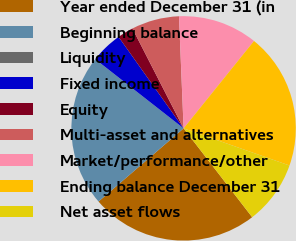<chart> <loc_0><loc_0><loc_500><loc_500><pie_chart><fcel>Year ended December 31 (in<fcel>Beginning balance<fcel>Liquidity<fcel>Fixed income<fcel>Equity<fcel>Multi-asset and alternatives<fcel>Market/performance/other<fcel>Ending balance December 31<fcel>Net asset flows<nl><fcel>24.16%<fcel>21.87%<fcel>0.01%<fcel>4.59%<fcel>2.3%<fcel>6.88%<fcel>11.45%<fcel>19.58%<fcel>9.17%<nl></chart> 